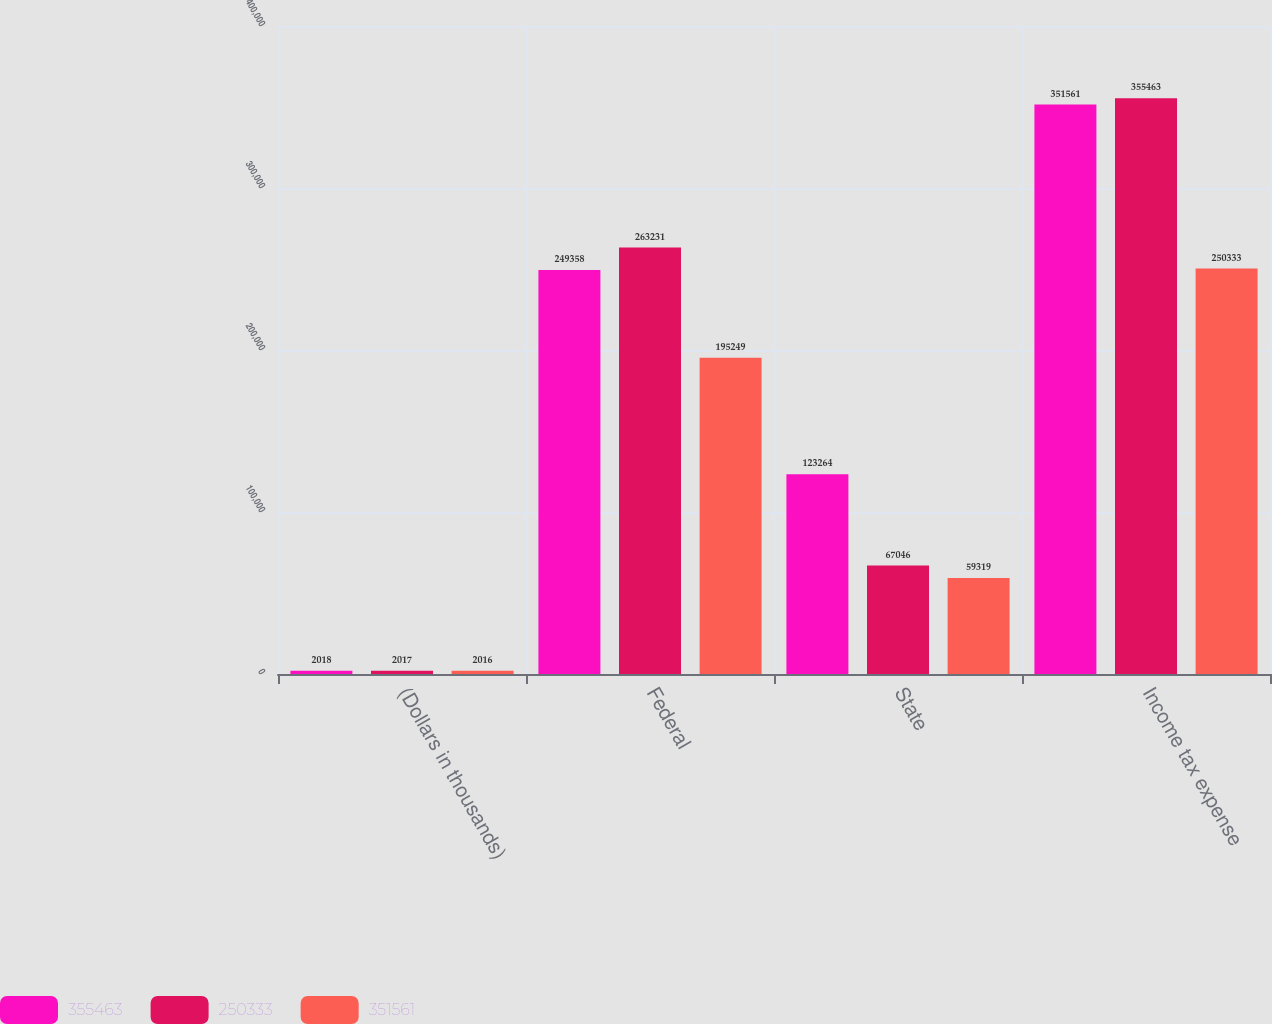Convert chart. <chart><loc_0><loc_0><loc_500><loc_500><stacked_bar_chart><ecel><fcel>(Dollars in thousands)<fcel>Federal<fcel>State<fcel>Income tax expense<nl><fcel>355463<fcel>2018<fcel>249358<fcel>123264<fcel>351561<nl><fcel>250333<fcel>2017<fcel>263231<fcel>67046<fcel>355463<nl><fcel>351561<fcel>2016<fcel>195249<fcel>59319<fcel>250333<nl></chart> 